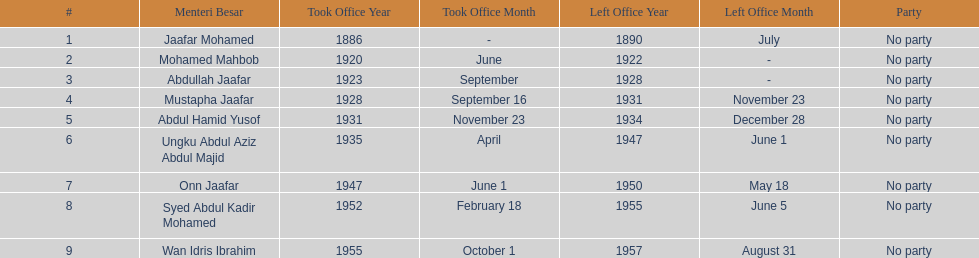Who was the first to take office? Jaafar Mohamed. 